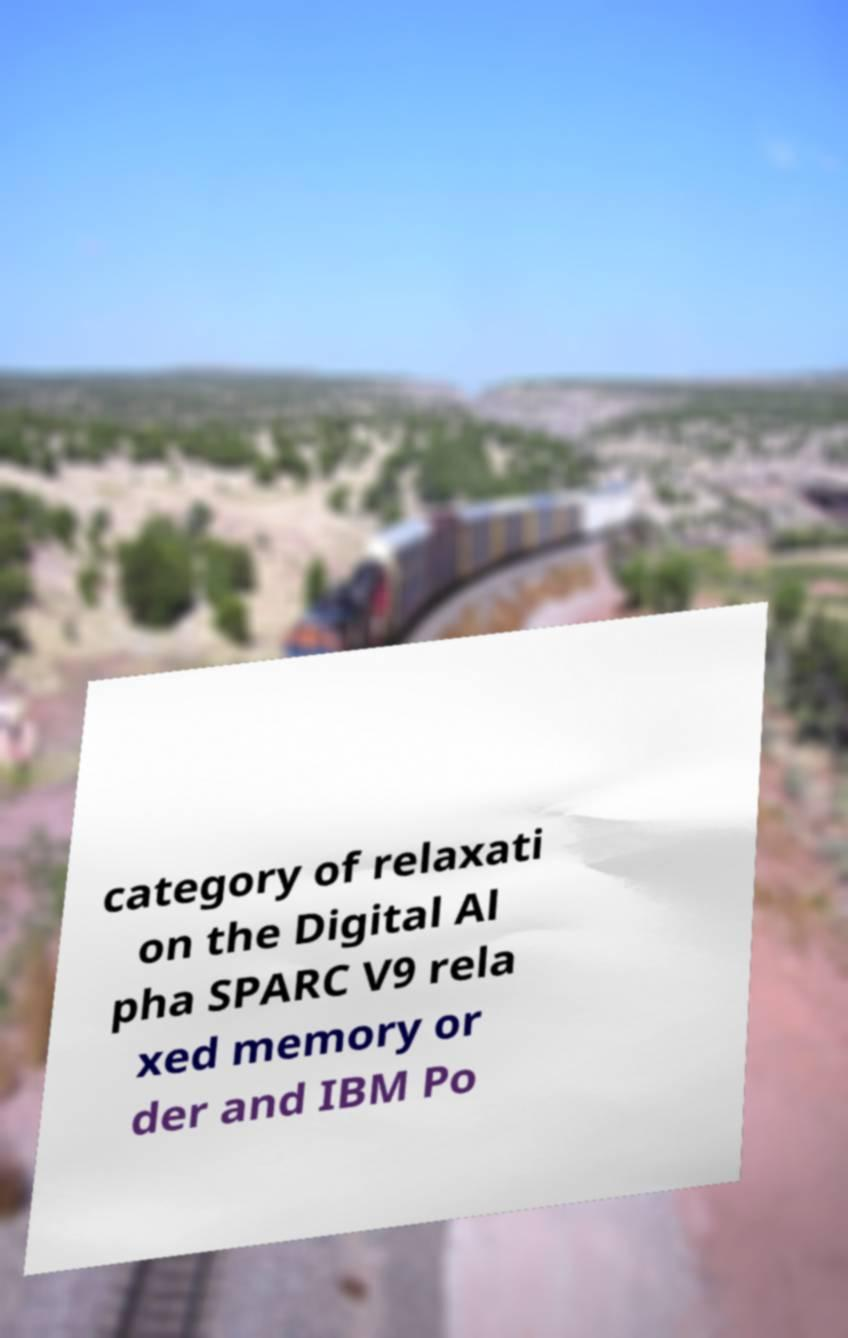There's text embedded in this image that I need extracted. Can you transcribe it verbatim? category of relaxati on the Digital Al pha SPARC V9 rela xed memory or der and IBM Po 